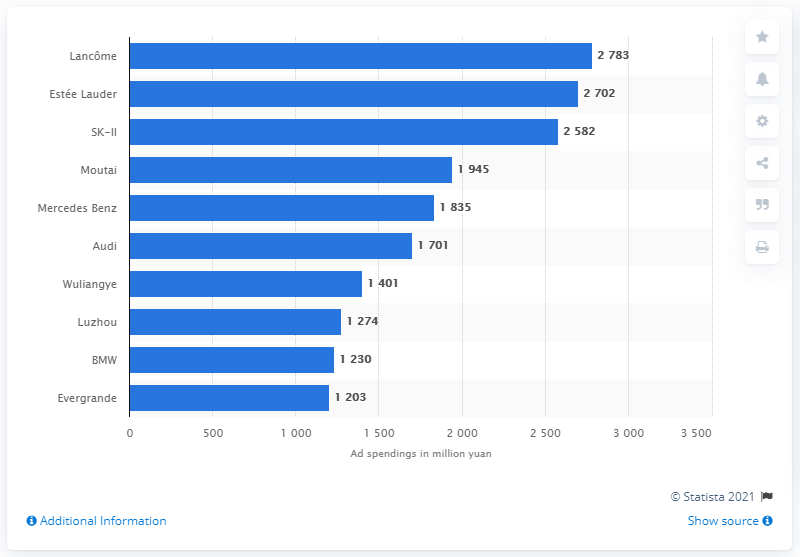Mention a couple of crucial points in this snapshot. In 2011, Evergrande spent 1203 on advertising. In 2011, the real estate developer Evergrande spent 1.2 billion yuan on advertising. 